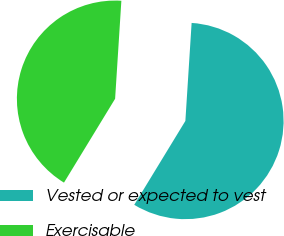Convert chart. <chart><loc_0><loc_0><loc_500><loc_500><pie_chart><fcel>Vested or expected to vest<fcel>Exercisable<nl><fcel>57.7%<fcel>42.3%<nl></chart> 